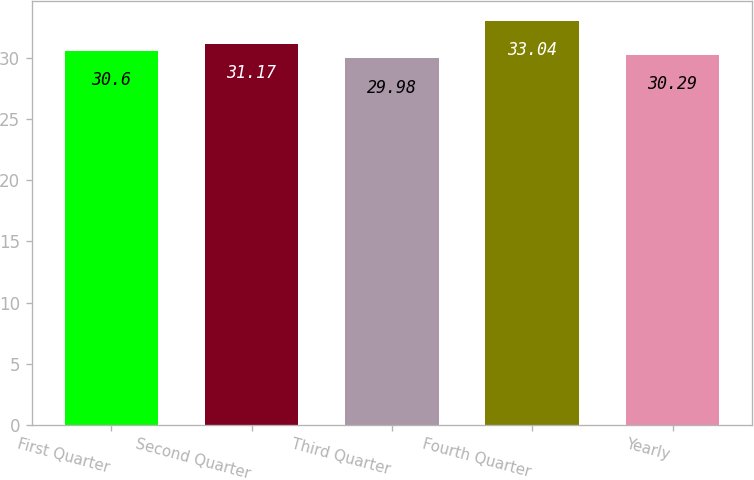Convert chart to OTSL. <chart><loc_0><loc_0><loc_500><loc_500><bar_chart><fcel>First Quarter<fcel>Second Quarter<fcel>Third Quarter<fcel>Fourth Quarter<fcel>Yearly<nl><fcel>30.6<fcel>31.17<fcel>29.98<fcel>33.04<fcel>30.29<nl></chart> 